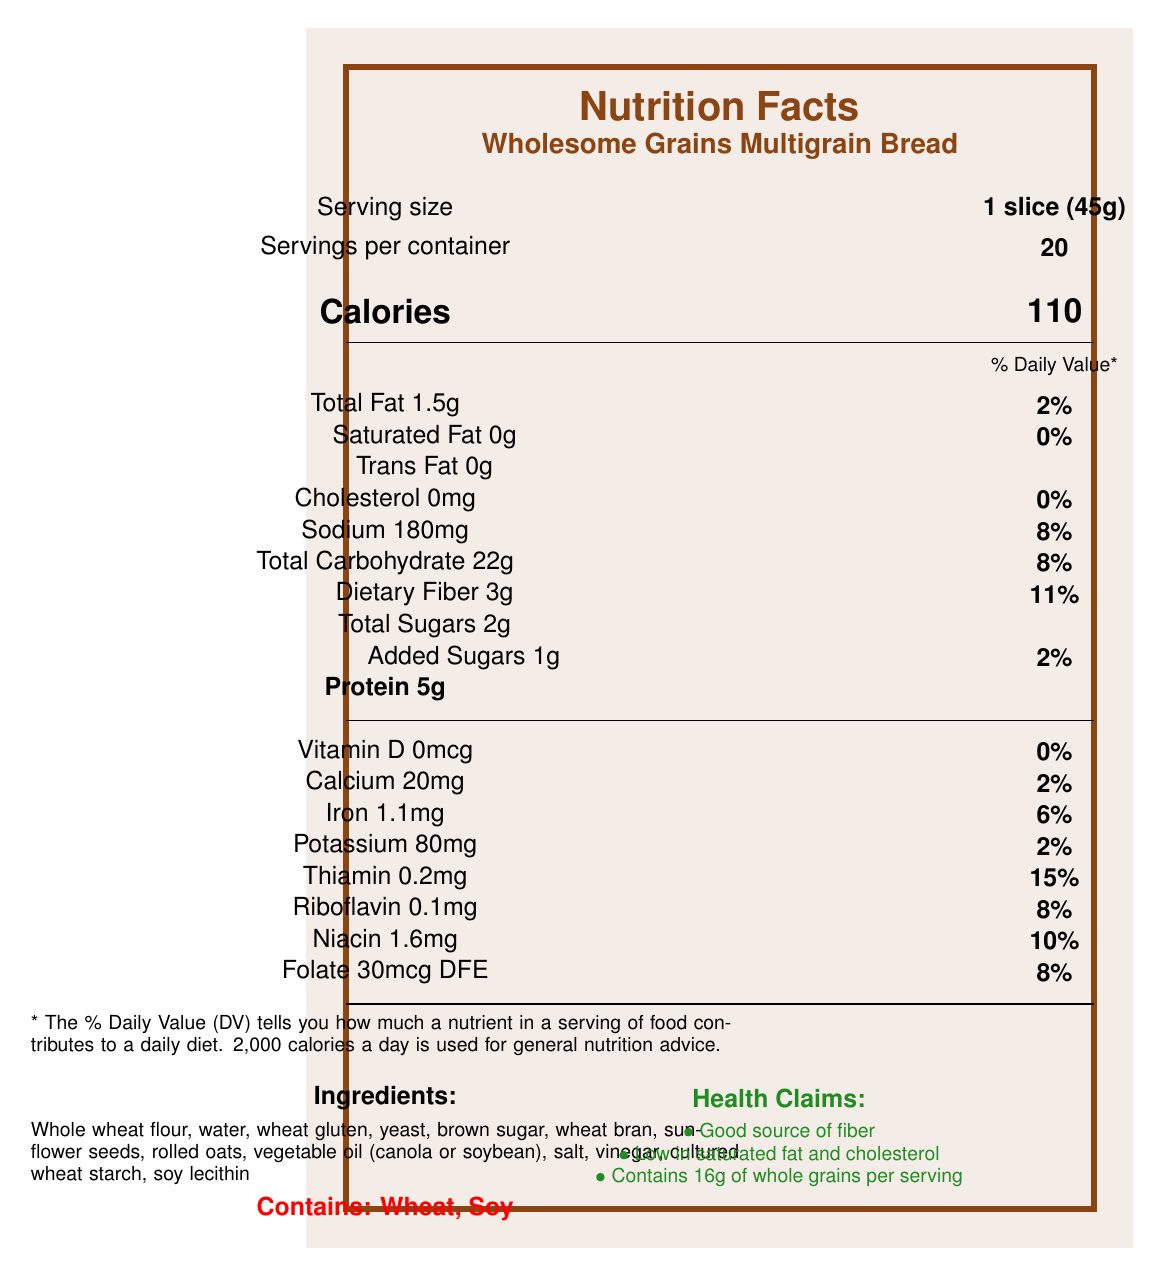what is the serving size for Wholesome Grains Multigrain Bread? The serving size is indicated at the top of the label as "1 slice (45g)".
Answer: 1 slice (45g) how much protein does one serving of the bread provide? The amount of protein per serving can be found under the nutrient information listed as "Protein 5g".
Answer: 5g what is the daily value percentage for dietary fiber in each serving? The daily value percentage for dietary fiber is located next to the amount listed as "Dietary Fiber 3g 11%".
Answer: 11% how much calcium is in a serving of the bread? The calcium content is listed in the vitamin and mineral information section as "Calcium 20mg".
Answer: 20mg which minerals are listed with a daily value percentage on the label? The minerals listed with daily value percentages are calcium (2%), iron (6%), and potassium (2%).
Answer: Calcium, Iron, Potassium how many total sugars are in one slice of bread? The total sugars per serving are listed as "Total Sugars 2g".
Answer: 2g What is the percentage of the daily value for sodium based on one serving? The daily value percentage for sodium is shown next to the amount listed as "Sodium 180mg 8%".
Answer: 8% Which vitamin has the highest daily value percentage in one serving of the bread? a) Vitamin D b) Riboflavin c) Thiamin d) Folate Thiamin has a daily value percentage of 15%, which is higher than the others listed in the vitamin and mineral information.
Answer: c) Thiamin How many calories are in two slices of Wholesome Grains Multigrain Bread? a) 110 b) 220 c) 330 d) 440 One slice contains 110 calories, so two slices would contain 110 calories x 2 = 220 calories.
Answer: b) 220 Is the bread free of cholesterol? The cholesterol content is listed as "Cholesterol 0mg 0%", indicating that there is no cholesterol in the bread.
Answer: Yes Summarize the main nutritional benefits of Wholesome Grains Multigrain Bread. The bread offers several nutritional advantages, including 5g of protein, 3g of dietary fiber, and is low in saturated fat and cholesterol. It also provides significant whole grain content and essential minerals for children's growth and health.
Answer: The bread is a good source of protein and fiber, low in saturated fat and cholesterol, and contains essential minerals like iron and potassium. It provides 16g of whole grains per serving and helps support digestion and energy levels. What type of vegetable oil is used in the bread? The ingredients list mentions vegetable oil but specifies it could be either canola or soybean oil, so the exact type is not determined.
Answer: Cannot be determined What is the main purpose of the health claims on the label? The health claims emphasize attributes like being a good source of fiber, low in saturated fat and cholesterol, and containing 16g of whole grains per serving to attract health-conscious consumers.
Answer: To highlight the nutritional benefits of the bread 